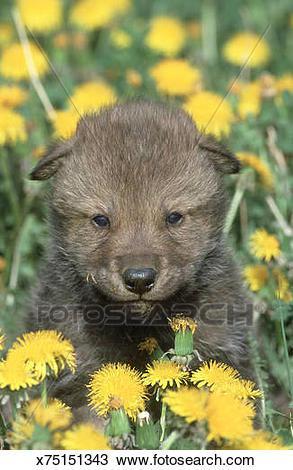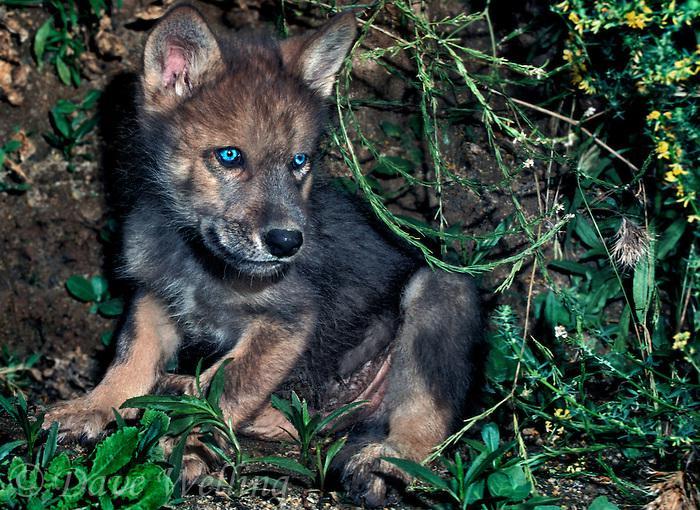The first image is the image on the left, the second image is the image on the right. Evaluate the accuracy of this statement regarding the images: "There is at least three wolves.". Is it true? Answer yes or no. No. The first image is the image on the left, the second image is the image on the right. For the images shown, is this caption "In one of the images, there are two young wolves." true? Answer yes or no. Yes. 